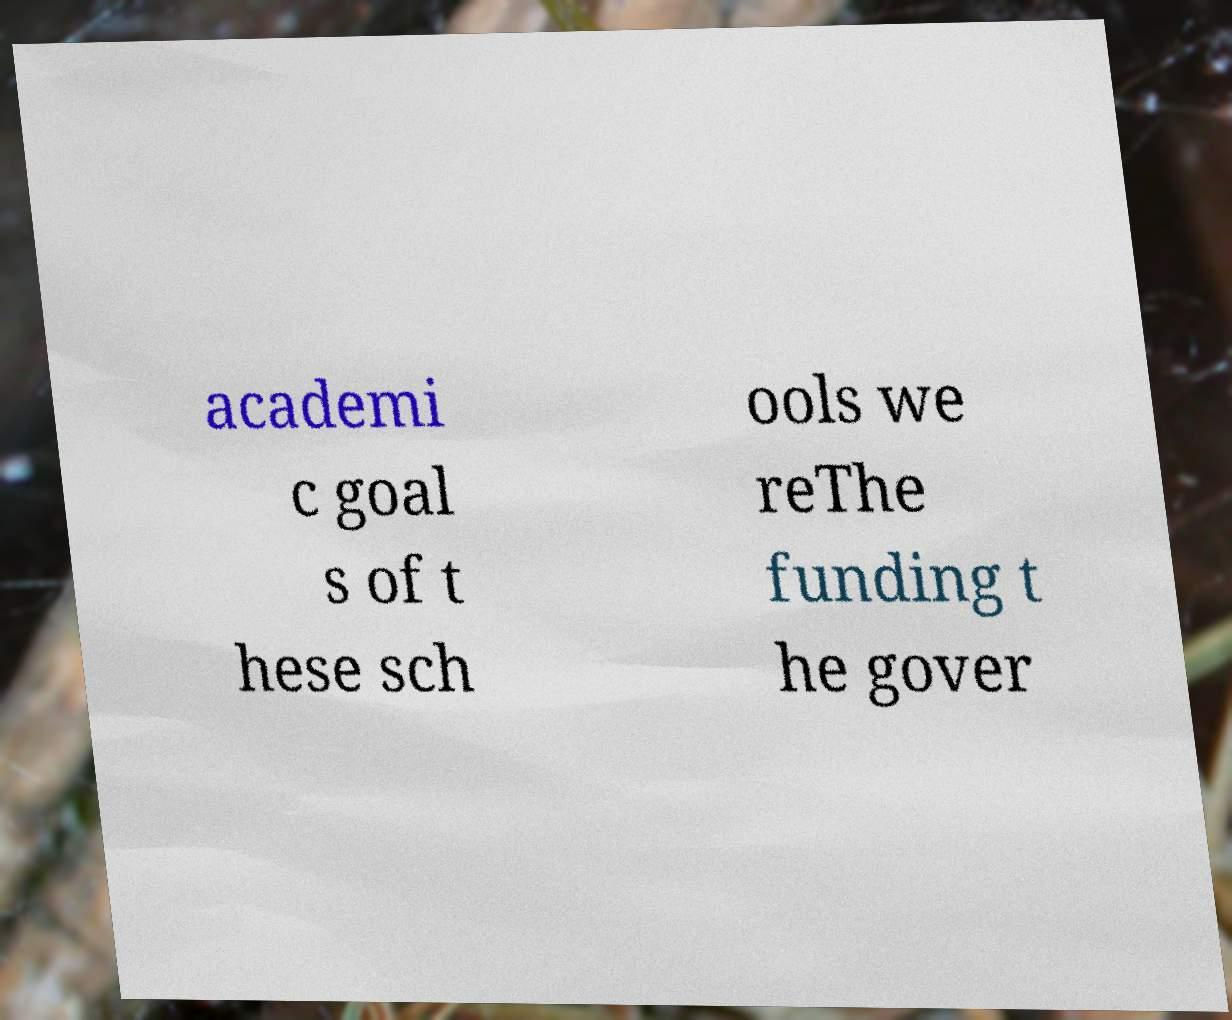Can you accurately transcribe the text from the provided image for me? academi c goal s of t hese sch ools we reThe funding t he gover 